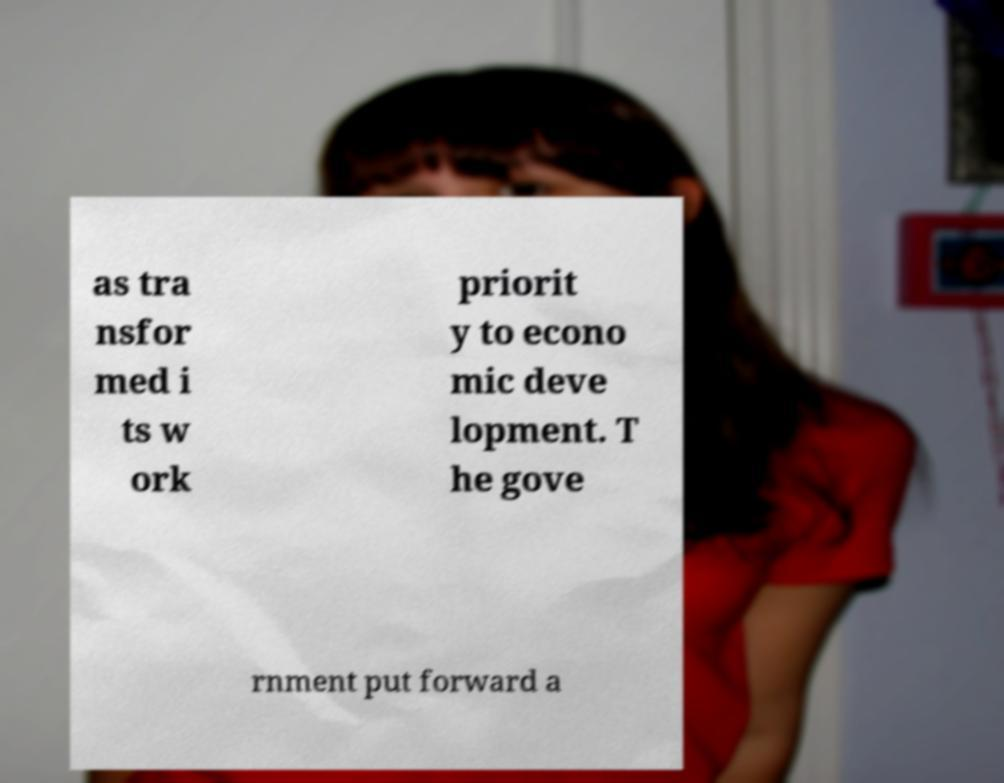Please read and relay the text visible in this image. What does it say? as tra nsfor med i ts w ork priorit y to econo mic deve lopment. T he gove rnment put forward a 